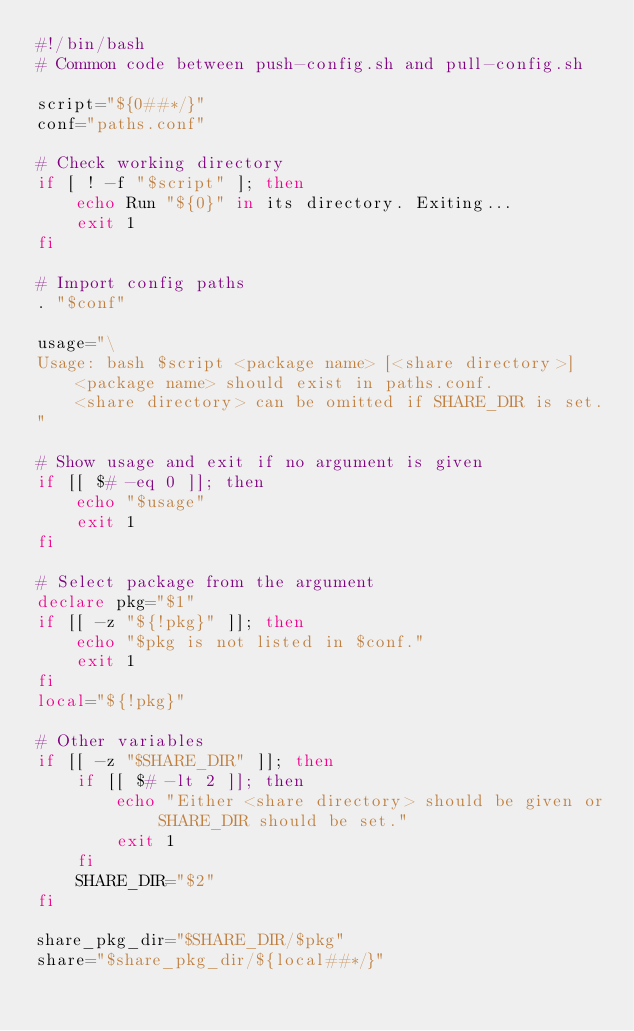<code> <loc_0><loc_0><loc_500><loc_500><_Bash_>#!/bin/bash
# Common code between push-config.sh and pull-config.sh

script="${0##*/}"
conf="paths.conf"

# Check working directory
if [ ! -f "$script" ]; then
    echo Run "${0}" in its directory. Exiting...
    exit 1
fi

# Import config paths
. "$conf"

usage="\
Usage: bash $script <package name> [<share directory>]
    <package name> should exist in paths.conf.
    <share directory> can be omitted if SHARE_DIR is set.
"

# Show usage and exit if no argument is given
if [[ $# -eq 0 ]]; then
    echo "$usage"
    exit 1
fi

# Select package from the argument
declare pkg="$1"
if [[ -z "${!pkg}" ]]; then
    echo "$pkg is not listed in $conf."
    exit 1
fi
local="${!pkg}"

# Other variables
if [[ -z "$SHARE_DIR" ]]; then
    if [[ $# -lt 2 ]]; then
        echo "Either <share directory> should be given or SHARE_DIR should be set."
        exit 1
    fi
    SHARE_DIR="$2"
fi

share_pkg_dir="$SHARE_DIR/$pkg"
share="$share_pkg_dir/${local##*/}"
</code> 